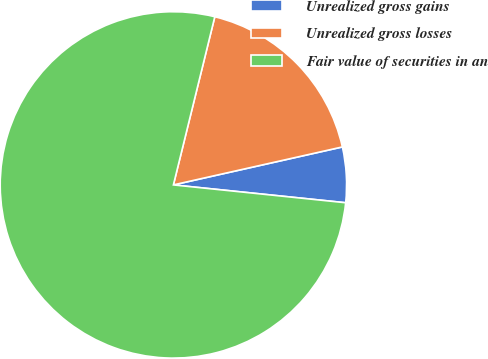<chart> <loc_0><loc_0><loc_500><loc_500><pie_chart><fcel>Unrealized gross gains<fcel>Unrealized gross losses<fcel>Fair value of securities in an<nl><fcel>5.16%<fcel>17.64%<fcel>77.2%<nl></chart> 